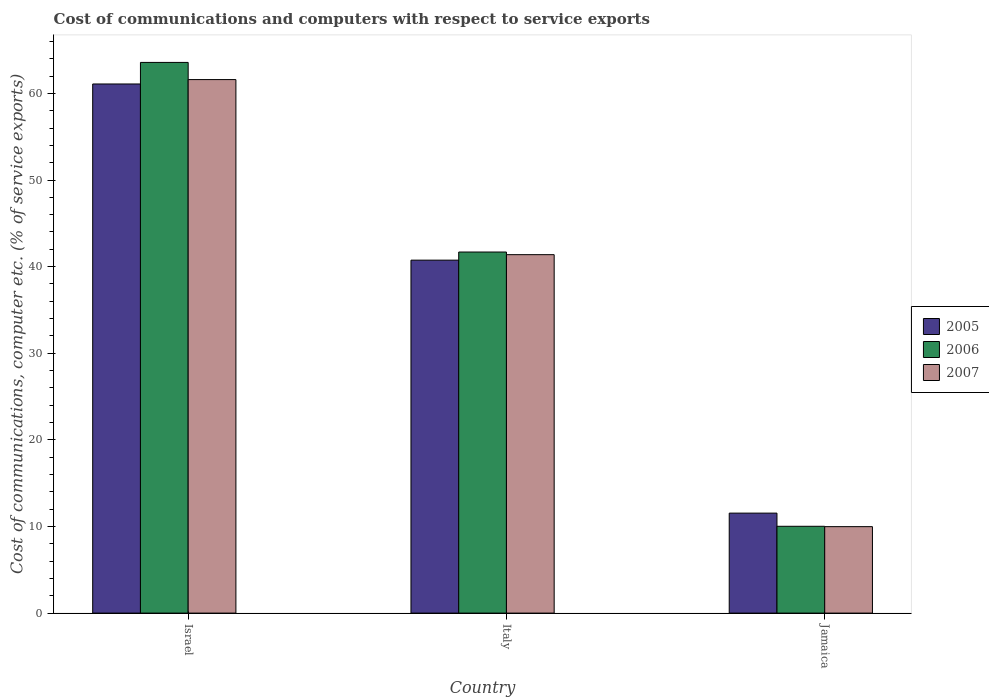Are the number of bars on each tick of the X-axis equal?
Your answer should be compact. Yes. What is the cost of communications and computers in 2006 in Italy?
Provide a short and direct response. 41.69. Across all countries, what is the maximum cost of communications and computers in 2005?
Keep it short and to the point. 61.09. Across all countries, what is the minimum cost of communications and computers in 2005?
Your answer should be compact. 11.54. In which country was the cost of communications and computers in 2005 maximum?
Offer a very short reply. Israel. In which country was the cost of communications and computers in 2005 minimum?
Provide a succinct answer. Jamaica. What is the total cost of communications and computers in 2006 in the graph?
Provide a short and direct response. 115.28. What is the difference between the cost of communications and computers in 2006 in Israel and that in Jamaica?
Provide a short and direct response. 53.55. What is the difference between the cost of communications and computers in 2007 in Jamaica and the cost of communications and computers in 2005 in Israel?
Give a very brief answer. -51.11. What is the average cost of communications and computers in 2005 per country?
Give a very brief answer. 37.79. What is the difference between the cost of communications and computers of/in 2007 and cost of communications and computers of/in 2006 in Jamaica?
Your answer should be very brief. -0.04. What is the ratio of the cost of communications and computers in 2007 in Israel to that in Jamaica?
Offer a terse response. 6.17. Is the cost of communications and computers in 2006 in Israel less than that in Jamaica?
Offer a very short reply. No. What is the difference between the highest and the second highest cost of communications and computers in 2007?
Your answer should be very brief. -20.21. What is the difference between the highest and the lowest cost of communications and computers in 2006?
Ensure brevity in your answer.  53.55. In how many countries, is the cost of communications and computers in 2005 greater than the average cost of communications and computers in 2005 taken over all countries?
Ensure brevity in your answer.  2. What does the 1st bar from the right in Jamaica represents?
Your answer should be very brief. 2007. Is it the case that in every country, the sum of the cost of communications and computers in 2007 and cost of communications and computers in 2006 is greater than the cost of communications and computers in 2005?
Keep it short and to the point. Yes. How many bars are there?
Offer a very short reply. 9. What is the difference between two consecutive major ticks on the Y-axis?
Offer a very short reply. 10. Are the values on the major ticks of Y-axis written in scientific E-notation?
Offer a very short reply. No. Does the graph contain any zero values?
Give a very brief answer. No. Does the graph contain grids?
Offer a terse response. No. How are the legend labels stacked?
Keep it short and to the point. Vertical. What is the title of the graph?
Make the answer very short. Cost of communications and computers with respect to service exports. Does "1997" appear as one of the legend labels in the graph?
Offer a very short reply. No. What is the label or title of the Y-axis?
Offer a terse response. Cost of communications, computer etc. (% of service exports). What is the Cost of communications, computer etc. (% of service exports) in 2005 in Israel?
Offer a very short reply. 61.09. What is the Cost of communications, computer etc. (% of service exports) in 2006 in Israel?
Keep it short and to the point. 63.58. What is the Cost of communications, computer etc. (% of service exports) in 2007 in Israel?
Ensure brevity in your answer.  61.59. What is the Cost of communications, computer etc. (% of service exports) in 2005 in Italy?
Make the answer very short. 40.75. What is the Cost of communications, computer etc. (% of service exports) in 2006 in Italy?
Keep it short and to the point. 41.69. What is the Cost of communications, computer etc. (% of service exports) in 2007 in Italy?
Your answer should be compact. 41.38. What is the Cost of communications, computer etc. (% of service exports) in 2005 in Jamaica?
Provide a short and direct response. 11.54. What is the Cost of communications, computer etc. (% of service exports) of 2006 in Jamaica?
Offer a terse response. 10.02. What is the Cost of communications, computer etc. (% of service exports) of 2007 in Jamaica?
Your answer should be compact. 9.98. Across all countries, what is the maximum Cost of communications, computer etc. (% of service exports) in 2005?
Give a very brief answer. 61.09. Across all countries, what is the maximum Cost of communications, computer etc. (% of service exports) in 2006?
Ensure brevity in your answer.  63.58. Across all countries, what is the maximum Cost of communications, computer etc. (% of service exports) of 2007?
Give a very brief answer. 61.59. Across all countries, what is the minimum Cost of communications, computer etc. (% of service exports) of 2005?
Your answer should be compact. 11.54. Across all countries, what is the minimum Cost of communications, computer etc. (% of service exports) in 2006?
Ensure brevity in your answer.  10.02. Across all countries, what is the minimum Cost of communications, computer etc. (% of service exports) in 2007?
Your response must be concise. 9.98. What is the total Cost of communications, computer etc. (% of service exports) in 2005 in the graph?
Offer a very short reply. 113.38. What is the total Cost of communications, computer etc. (% of service exports) of 2006 in the graph?
Keep it short and to the point. 115.28. What is the total Cost of communications, computer etc. (% of service exports) in 2007 in the graph?
Your answer should be very brief. 112.95. What is the difference between the Cost of communications, computer etc. (% of service exports) in 2005 in Israel and that in Italy?
Provide a short and direct response. 20.34. What is the difference between the Cost of communications, computer etc. (% of service exports) in 2006 in Israel and that in Italy?
Offer a terse response. 21.89. What is the difference between the Cost of communications, computer etc. (% of service exports) of 2007 in Israel and that in Italy?
Provide a succinct answer. 20.21. What is the difference between the Cost of communications, computer etc. (% of service exports) in 2005 in Israel and that in Jamaica?
Give a very brief answer. 49.54. What is the difference between the Cost of communications, computer etc. (% of service exports) of 2006 in Israel and that in Jamaica?
Make the answer very short. 53.55. What is the difference between the Cost of communications, computer etc. (% of service exports) of 2007 in Israel and that in Jamaica?
Your response must be concise. 51.61. What is the difference between the Cost of communications, computer etc. (% of service exports) in 2005 in Italy and that in Jamaica?
Give a very brief answer. 29.2. What is the difference between the Cost of communications, computer etc. (% of service exports) in 2006 in Italy and that in Jamaica?
Provide a succinct answer. 31.66. What is the difference between the Cost of communications, computer etc. (% of service exports) of 2007 in Italy and that in Jamaica?
Your response must be concise. 31.4. What is the difference between the Cost of communications, computer etc. (% of service exports) of 2005 in Israel and the Cost of communications, computer etc. (% of service exports) of 2006 in Italy?
Your answer should be very brief. 19.4. What is the difference between the Cost of communications, computer etc. (% of service exports) in 2005 in Israel and the Cost of communications, computer etc. (% of service exports) in 2007 in Italy?
Your response must be concise. 19.71. What is the difference between the Cost of communications, computer etc. (% of service exports) of 2006 in Israel and the Cost of communications, computer etc. (% of service exports) of 2007 in Italy?
Your response must be concise. 22.2. What is the difference between the Cost of communications, computer etc. (% of service exports) in 2005 in Israel and the Cost of communications, computer etc. (% of service exports) in 2006 in Jamaica?
Provide a short and direct response. 51.07. What is the difference between the Cost of communications, computer etc. (% of service exports) of 2005 in Israel and the Cost of communications, computer etc. (% of service exports) of 2007 in Jamaica?
Make the answer very short. 51.11. What is the difference between the Cost of communications, computer etc. (% of service exports) in 2006 in Israel and the Cost of communications, computer etc. (% of service exports) in 2007 in Jamaica?
Give a very brief answer. 53.59. What is the difference between the Cost of communications, computer etc. (% of service exports) of 2005 in Italy and the Cost of communications, computer etc. (% of service exports) of 2006 in Jamaica?
Provide a short and direct response. 30.73. What is the difference between the Cost of communications, computer etc. (% of service exports) of 2005 in Italy and the Cost of communications, computer etc. (% of service exports) of 2007 in Jamaica?
Keep it short and to the point. 30.77. What is the difference between the Cost of communications, computer etc. (% of service exports) of 2006 in Italy and the Cost of communications, computer etc. (% of service exports) of 2007 in Jamaica?
Provide a succinct answer. 31.7. What is the average Cost of communications, computer etc. (% of service exports) of 2005 per country?
Offer a very short reply. 37.79. What is the average Cost of communications, computer etc. (% of service exports) of 2006 per country?
Your response must be concise. 38.43. What is the average Cost of communications, computer etc. (% of service exports) in 2007 per country?
Your response must be concise. 37.65. What is the difference between the Cost of communications, computer etc. (% of service exports) in 2005 and Cost of communications, computer etc. (% of service exports) in 2006 in Israel?
Provide a short and direct response. -2.49. What is the difference between the Cost of communications, computer etc. (% of service exports) of 2005 and Cost of communications, computer etc. (% of service exports) of 2007 in Israel?
Your answer should be compact. -0.51. What is the difference between the Cost of communications, computer etc. (% of service exports) in 2006 and Cost of communications, computer etc. (% of service exports) in 2007 in Israel?
Your answer should be compact. 1.98. What is the difference between the Cost of communications, computer etc. (% of service exports) in 2005 and Cost of communications, computer etc. (% of service exports) in 2006 in Italy?
Provide a short and direct response. -0.94. What is the difference between the Cost of communications, computer etc. (% of service exports) of 2005 and Cost of communications, computer etc. (% of service exports) of 2007 in Italy?
Provide a succinct answer. -0.63. What is the difference between the Cost of communications, computer etc. (% of service exports) in 2006 and Cost of communications, computer etc. (% of service exports) in 2007 in Italy?
Your response must be concise. 0.31. What is the difference between the Cost of communications, computer etc. (% of service exports) in 2005 and Cost of communications, computer etc. (% of service exports) in 2006 in Jamaica?
Your response must be concise. 1.52. What is the difference between the Cost of communications, computer etc. (% of service exports) of 2005 and Cost of communications, computer etc. (% of service exports) of 2007 in Jamaica?
Ensure brevity in your answer.  1.56. What is the difference between the Cost of communications, computer etc. (% of service exports) of 2006 and Cost of communications, computer etc. (% of service exports) of 2007 in Jamaica?
Your answer should be compact. 0.04. What is the ratio of the Cost of communications, computer etc. (% of service exports) in 2005 in Israel to that in Italy?
Provide a short and direct response. 1.5. What is the ratio of the Cost of communications, computer etc. (% of service exports) in 2006 in Israel to that in Italy?
Provide a short and direct response. 1.53. What is the ratio of the Cost of communications, computer etc. (% of service exports) of 2007 in Israel to that in Italy?
Give a very brief answer. 1.49. What is the ratio of the Cost of communications, computer etc. (% of service exports) of 2005 in Israel to that in Jamaica?
Give a very brief answer. 5.29. What is the ratio of the Cost of communications, computer etc. (% of service exports) in 2006 in Israel to that in Jamaica?
Ensure brevity in your answer.  6.34. What is the ratio of the Cost of communications, computer etc. (% of service exports) in 2007 in Israel to that in Jamaica?
Your answer should be very brief. 6.17. What is the ratio of the Cost of communications, computer etc. (% of service exports) in 2005 in Italy to that in Jamaica?
Give a very brief answer. 3.53. What is the ratio of the Cost of communications, computer etc. (% of service exports) in 2006 in Italy to that in Jamaica?
Offer a terse response. 4.16. What is the ratio of the Cost of communications, computer etc. (% of service exports) of 2007 in Italy to that in Jamaica?
Your answer should be very brief. 4.15. What is the difference between the highest and the second highest Cost of communications, computer etc. (% of service exports) in 2005?
Provide a succinct answer. 20.34. What is the difference between the highest and the second highest Cost of communications, computer etc. (% of service exports) of 2006?
Ensure brevity in your answer.  21.89. What is the difference between the highest and the second highest Cost of communications, computer etc. (% of service exports) of 2007?
Make the answer very short. 20.21. What is the difference between the highest and the lowest Cost of communications, computer etc. (% of service exports) of 2005?
Offer a very short reply. 49.54. What is the difference between the highest and the lowest Cost of communications, computer etc. (% of service exports) in 2006?
Your answer should be compact. 53.55. What is the difference between the highest and the lowest Cost of communications, computer etc. (% of service exports) of 2007?
Your answer should be compact. 51.61. 